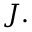<formula> <loc_0><loc_0><loc_500><loc_500>{ J } .</formula> 